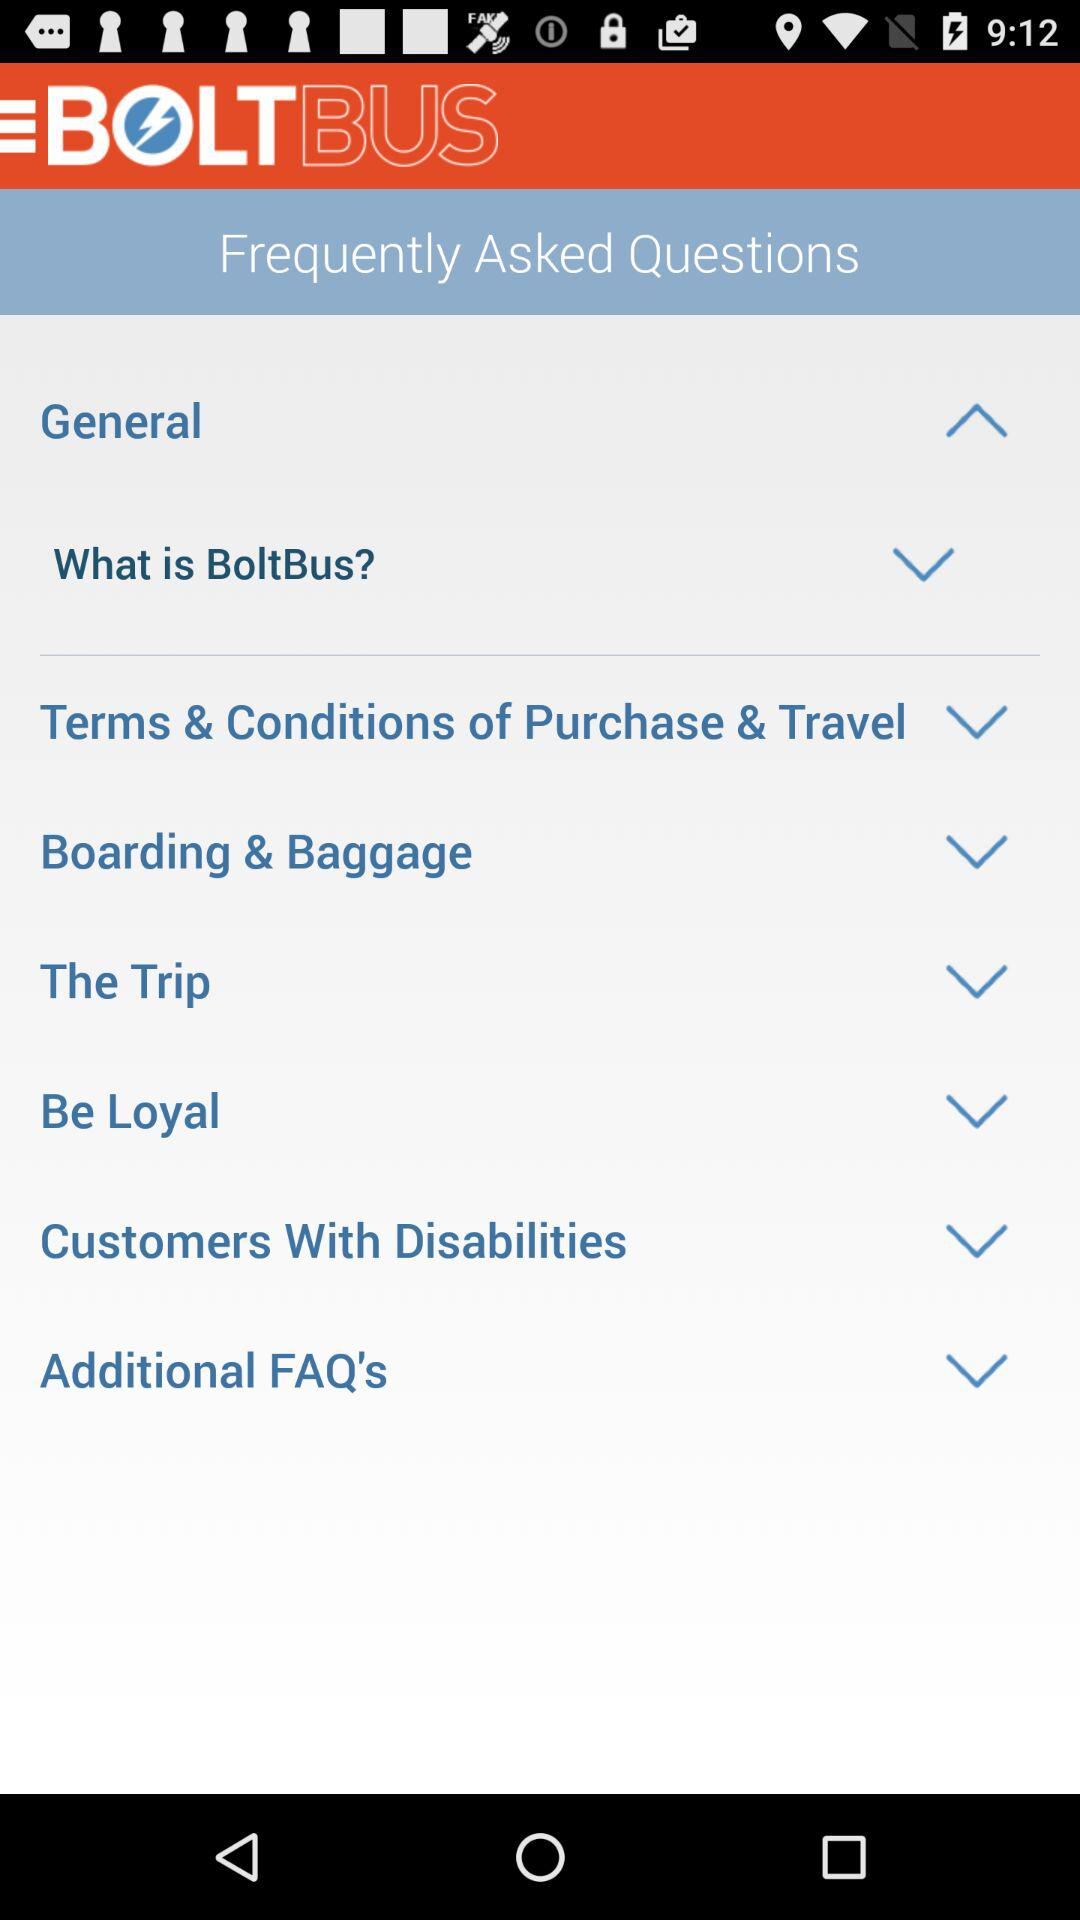What is the app name? The app name is "BOLTBUS". 